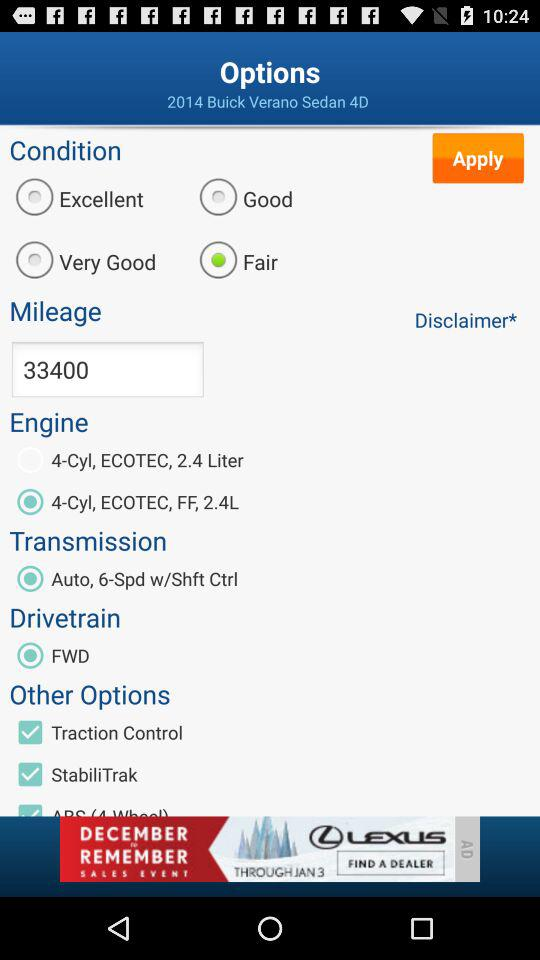Which option is selected for the "Condition"? The selected option is "Fair". 